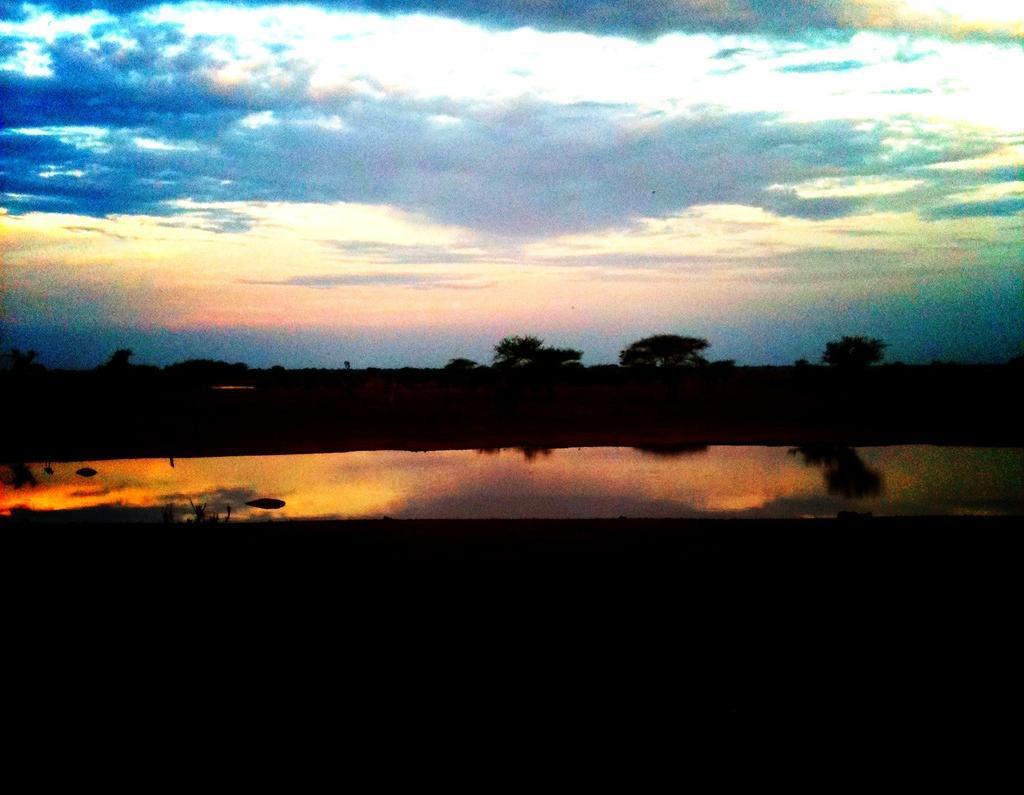Can you describe this image briefly? There is water in the foreground. There are trees at the background and the sky is cloudy at the top. 